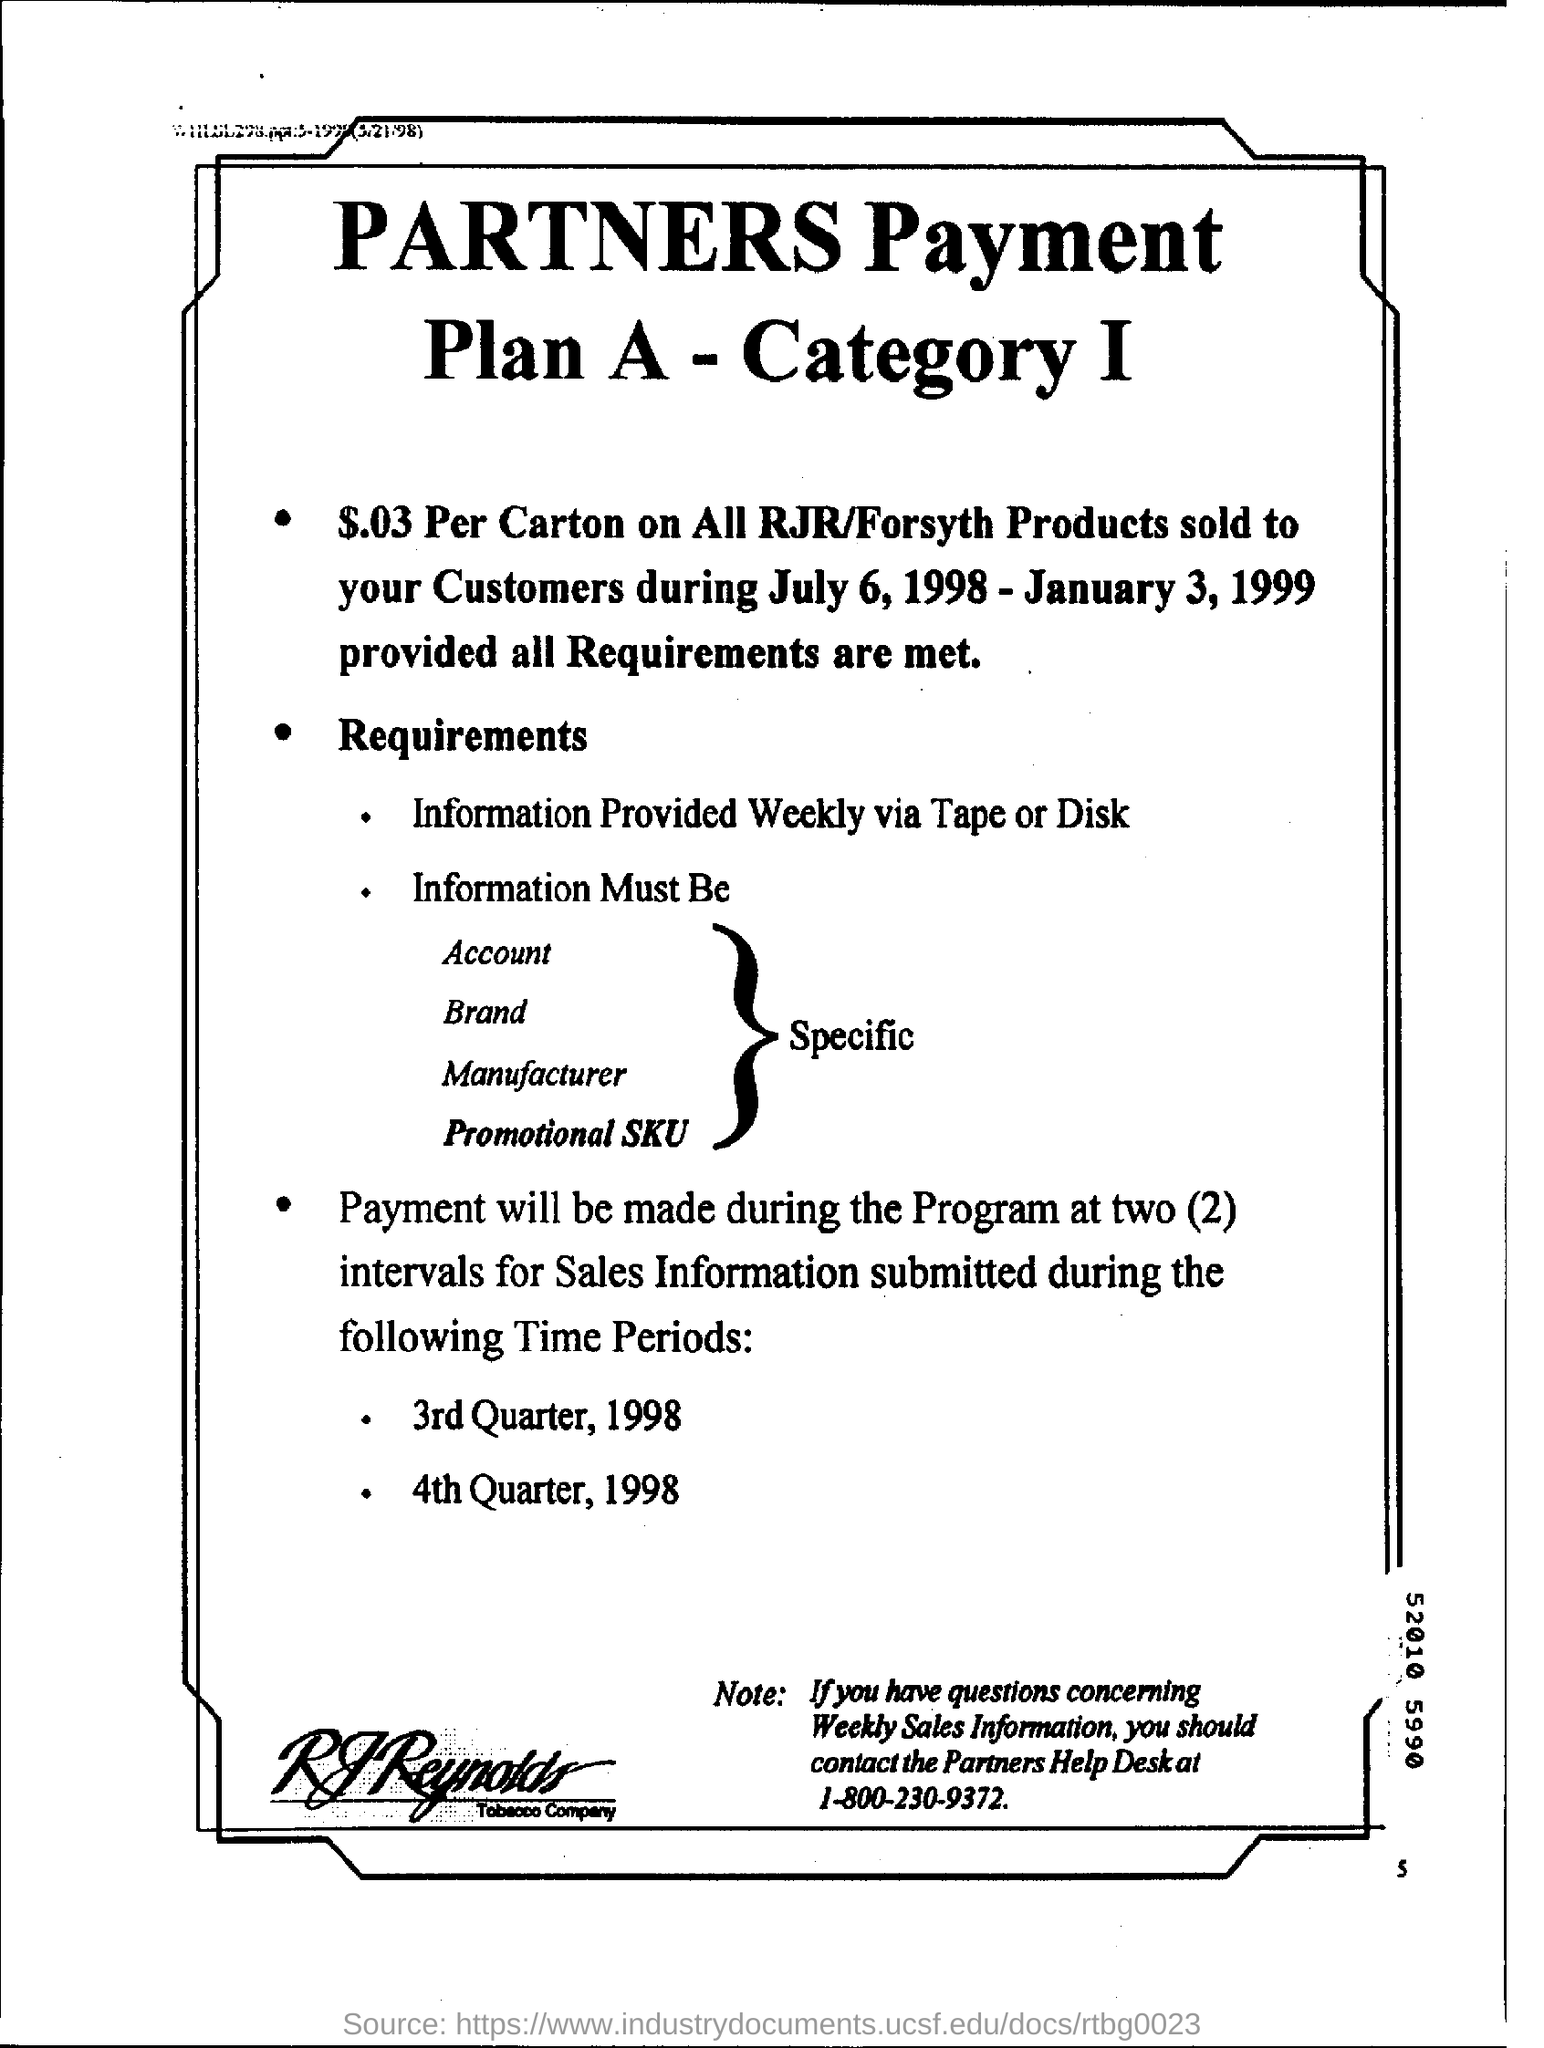Outline some significant characteristics in this image. Payment will be made during the program at two intervals. The price per carton will be $0.03. The payment will be made during the program. 